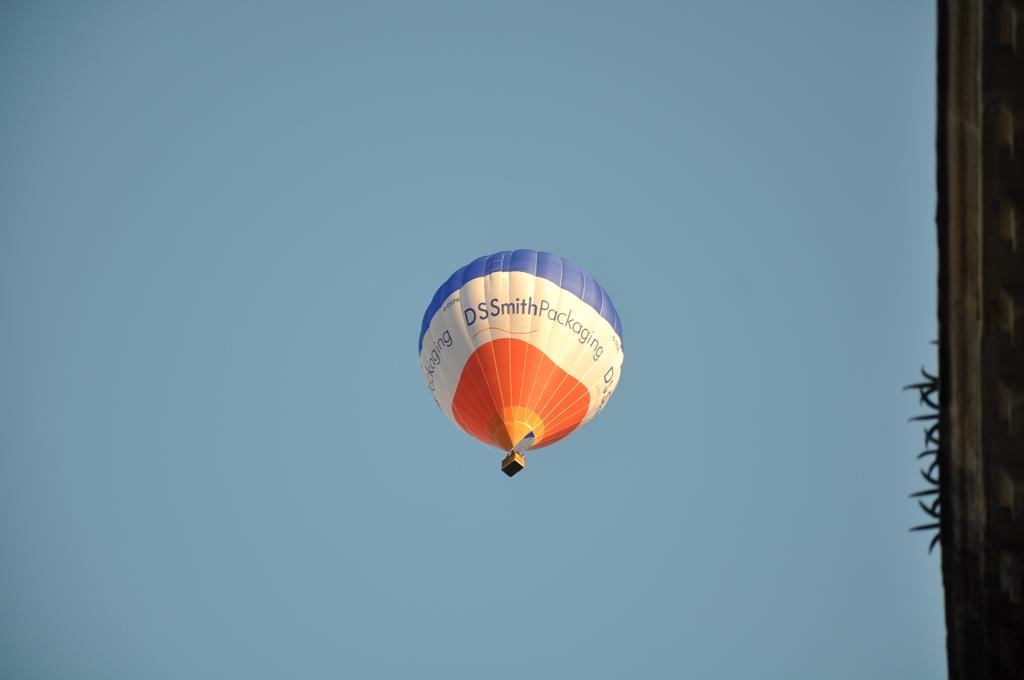<image>
Summarize the visual content of the image. Hot ballon with DSS Smith Packaging slogan on the side. 